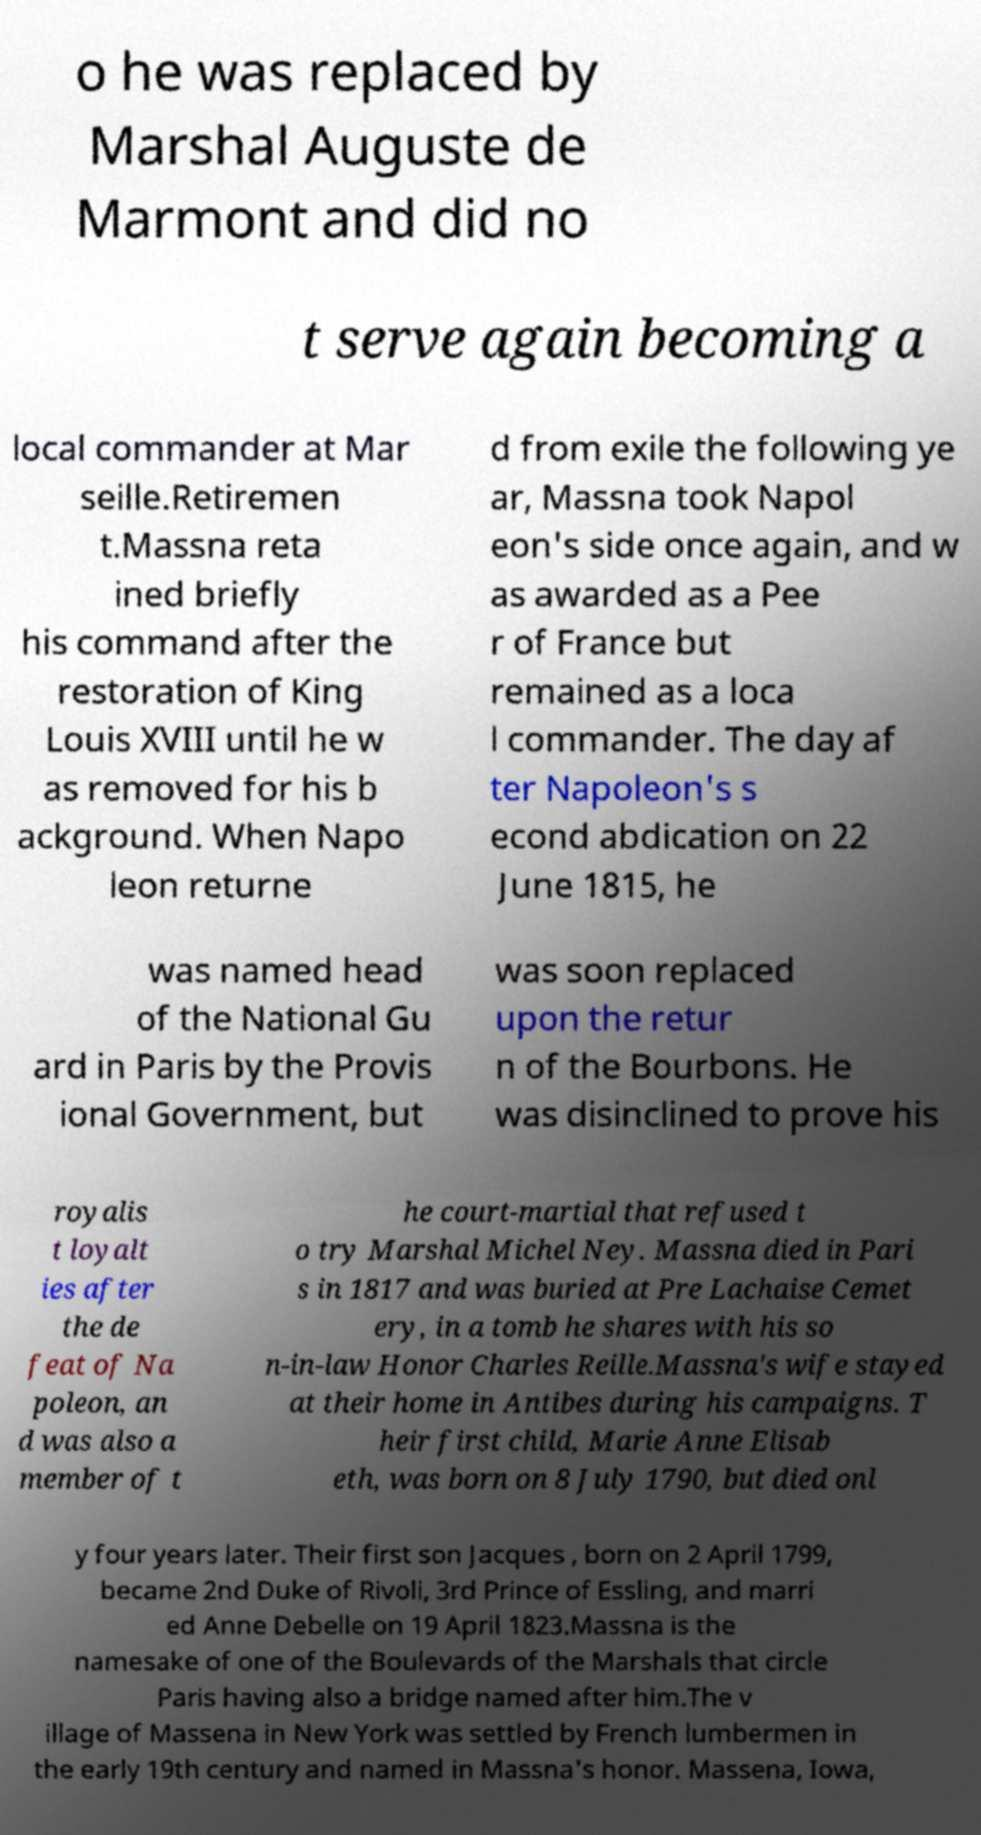What messages or text are displayed in this image? I need them in a readable, typed format. o he was replaced by Marshal Auguste de Marmont and did no t serve again becoming a local commander at Mar seille.Retiremen t.Massna reta ined briefly his command after the restoration of King Louis XVIII until he w as removed for his b ackground. When Napo leon returne d from exile the following ye ar, Massna took Napol eon's side once again, and w as awarded as a Pee r of France but remained as a loca l commander. The day af ter Napoleon's s econd abdication on 22 June 1815, he was named head of the National Gu ard in Paris by the Provis ional Government, but was soon replaced upon the retur n of the Bourbons. He was disinclined to prove his royalis t loyalt ies after the de feat of Na poleon, an d was also a member of t he court-martial that refused t o try Marshal Michel Ney. Massna died in Pari s in 1817 and was buried at Pre Lachaise Cemet ery, in a tomb he shares with his so n-in-law Honor Charles Reille.Massna's wife stayed at their home in Antibes during his campaigns. T heir first child, Marie Anne Elisab eth, was born on 8 July 1790, but died onl y four years later. Their first son Jacques , born on 2 April 1799, became 2nd Duke of Rivoli, 3rd Prince of Essling, and marri ed Anne Debelle on 19 April 1823.Massna is the namesake of one of the Boulevards of the Marshals that circle Paris having also a bridge named after him.The v illage of Massena in New York was settled by French lumbermen in the early 19th century and named in Massna's honor. Massena, Iowa, 